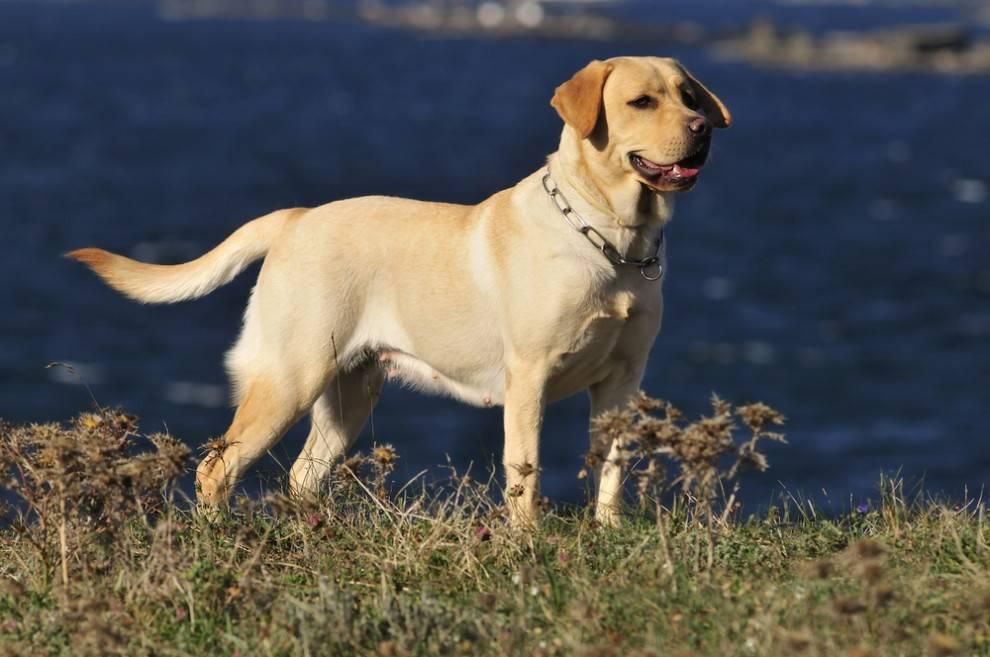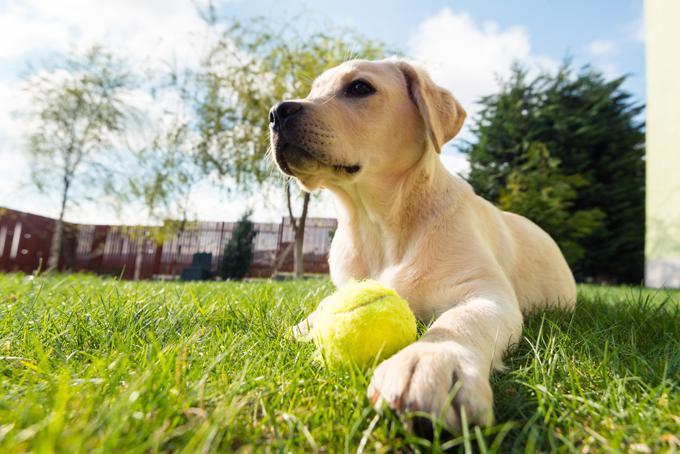The first image is the image on the left, the second image is the image on the right. Examine the images to the left and right. Is the description "An image contains exactly two dogs sitting upright, with the darker dog on the right." accurate? Answer yes or no. No. The first image is the image on the left, the second image is the image on the right. Analyze the images presented: Is the assertion "Four dogs exactly can be seen on the pair of images." valid? Answer yes or no. No. 